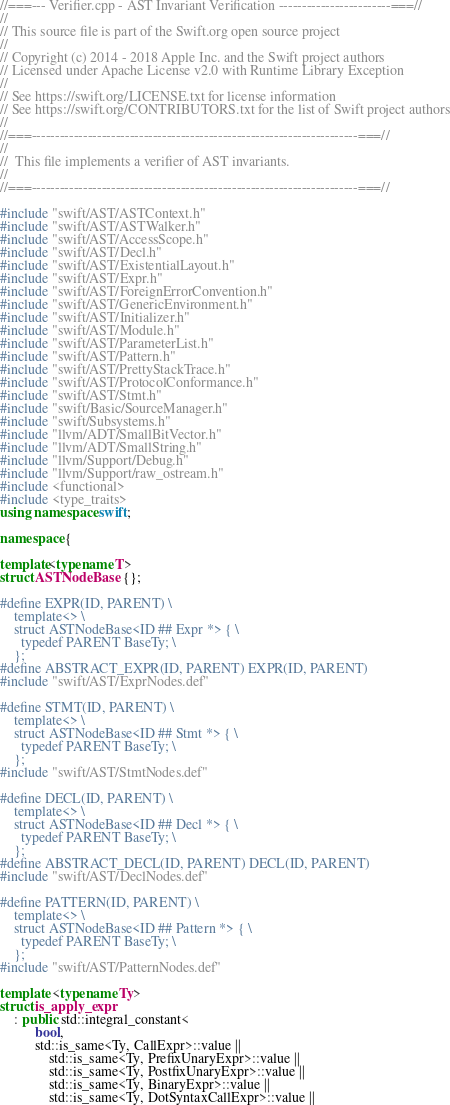<code> <loc_0><loc_0><loc_500><loc_500><_C++_>//===--- Verifier.cpp - AST Invariant Verification ------------------------===//
//
// This source file is part of the Swift.org open source project
//
// Copyright (c) 2014 - 2018 Apple Inc. and the Swift project authors
// Licensed under Apache License v2.0 with Runtime Library Exception
//
// See https://swift.org/LICENSE.txt for license information
// See https://swift.org/CONTRIBUTORS.txt for the list of Swift project authors
//
//===----------------------------------------------------------------------===//
//
//  This file implements a verifier of AST invariants.
//
//===----------------------------------------------------------------------===//

#include "swift/AST/ASTContext.h"
#include "swift/AST/ASTWalker.h"
#include "swift/AST/AccessScope.h"
#include "swift/AST/Decl.h"
#include "swift/AST/ExistentialLayout.h"
#include "swift/AST/Expr.h"
#include "swift/AST/ForeignErrorConvention.h"
#include "swift/AST/GenericEnvironment.h"
#include "swift/AST/Initializer.h"
#include "swift/AST/Module.h"
#include "swift/AST/ParameterList.h"
#include "swift/AST/Pattern.h"
#include "swift/AST/PrettyStackTrace.h"
#include "swift/AST/ProtocolConformance.h"
#include "swift/AST/Stmt.h"
#include "swift/Basic/SourceManager.h"
#include "swift/Subsystems.h"
#include "llvm/ADT/SmallBitVector.h"
#include "llvm/ADT/SmallString.h"
#include "llvm/Support/Debug.h"
#include "llvm/Support/raw_ostream.h"
#include <functional>
#include <type_traits>
using namespace swift;

namespace {

template<typename T>
struct ASTNodeBase {};

#define EXPR(ID, PARENT) \
    template<> \
    struct ASTNodeBase<ID ## Expr *> { \
      typedef PARENT BaseTy; \
    };
#define ABSTRACT_EXPR(ID, PARENT) EXPR(ID, PARENT)
#include "swift/AST/ExprNodes.def"

#define STMT(ID, PARENT) \
    template<> \
    struct ASTNodeBase<ID ## Stmt *> { \
      typedef PARENT BaseTy; \
    };
#include "swift/AST/StmtNodes.def"

#define DECL(ID, PARENT) \
    template<> \
    struct ASTNodeBase<ID ## Decl *> { \
      typedef PARENT BaseTy; \
    };
#define ABSTRACT_DECL(ID, PARENT) DECL(ID, PARENT)
#include "swift/AST/DeclNodes.def"

#define PATTERN(ID, PARENT) \
    template<> \
    struct ASTNodeBase<ID ## Pattern *> { \
      typedef PARENT BaseTy; \
    };
#include "swift/AST/PatternNodes.def"

template <typename Ty>
struct is_apply_expr
    : public std::integral_constant<
          bool,
          std::is_same<Ty, CallExpr>::value ||
              std::is_same<Ty, PrefixUnaryExpr>::value ||
              std::is_same<Ty, PostfixUnaryExpr>::value ||
              std::is_same<Ty, BinaryExpr>::value ||
              std::is_same<Ty, DotSyntaxCallExpr>::value ||</code> 